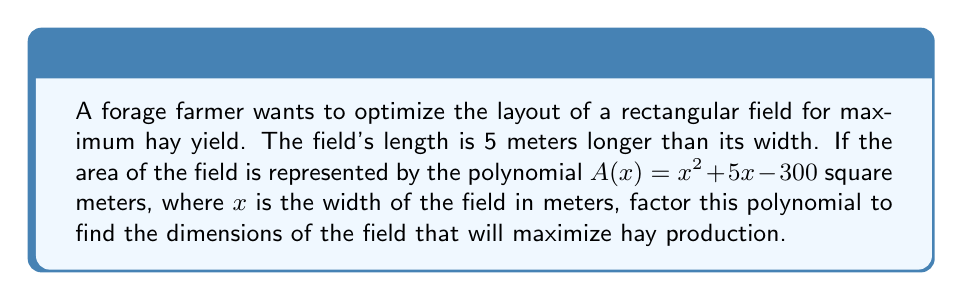Can you answer this question? To optimize the field layout, we need to factor the given polynomial $A(x) = x^2 + 5x - 300$.

Step 1: Identify the polynomial
$A(x) = x^2 + 5x - 300$

Step 2: Use the ac-method to factor
a) Multiply $a$ and $c$: $1 \times (-300) = -300$
b) Find two factors of -300 that add up to $b$ (5): $20$ and $-15$

Step 3: Rewrite the middle term
$A(x) = x^2 + 20x - 15x - 300$

Step 4: Group the terms
$A(x) = (x^2 + 20x) + (-15x - 300)$

Step 5: Factor out the common factor from each group
$A(x) = x(x + 20) - 15(x + 20)$

Step 6: Factor out the common binomial
$A(x) = (x - 15)(x + 20)$

The factored polynomial is $(x - 15)(x + 20)$.

To find the dimensions:
Width = $x$ meters
Length = $(x + 5)$ meters

From the factored form:
$x - 15 = 0$ or $x + 20 = 0$
$x = 15$ or $x = -20$

Since width cannot be negative, $x = 15$ meters.

Therefore:
Width = 15 meters
Length = $15 + 5 = 20$ meters
Answer: $(x - 15)(x + 20)$; Width = 15 m, Length = 20 m 